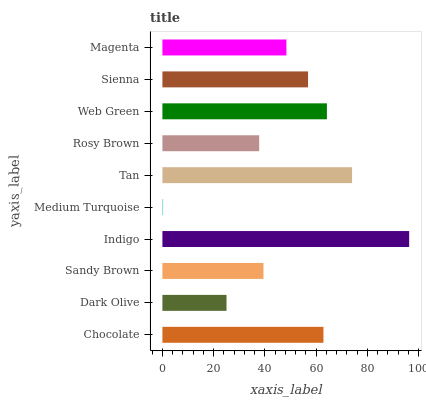Is Medium Turquoise the minimum?
Answer yes or no. Yes. Is Indigo the maximum?
Answer yes or no. Yes. Is Dark Olive the minimum?
Answer yes or no. No. Is Dark Olive the maximum?
Answer yes or no. No. Is Chocolate greater than Dark Olive?
Answer yes or no. Yes. Is Dark Olive less than Chocolate?
Answer yes or no. Yes. Is Dark Olive greater than Chocolate?
Answer yes or no. No. Is Chocolate less than Dark Olive?
Answer yes or no. No. Is Sienna the high median?
Answer yes or no. Yes. Is Magenta the low median?
Answer yes or no. Yes. Is Chocolate the high median?
Answer yes or no. No. Is Chocolate the low median?
Answer yes or no. No. 